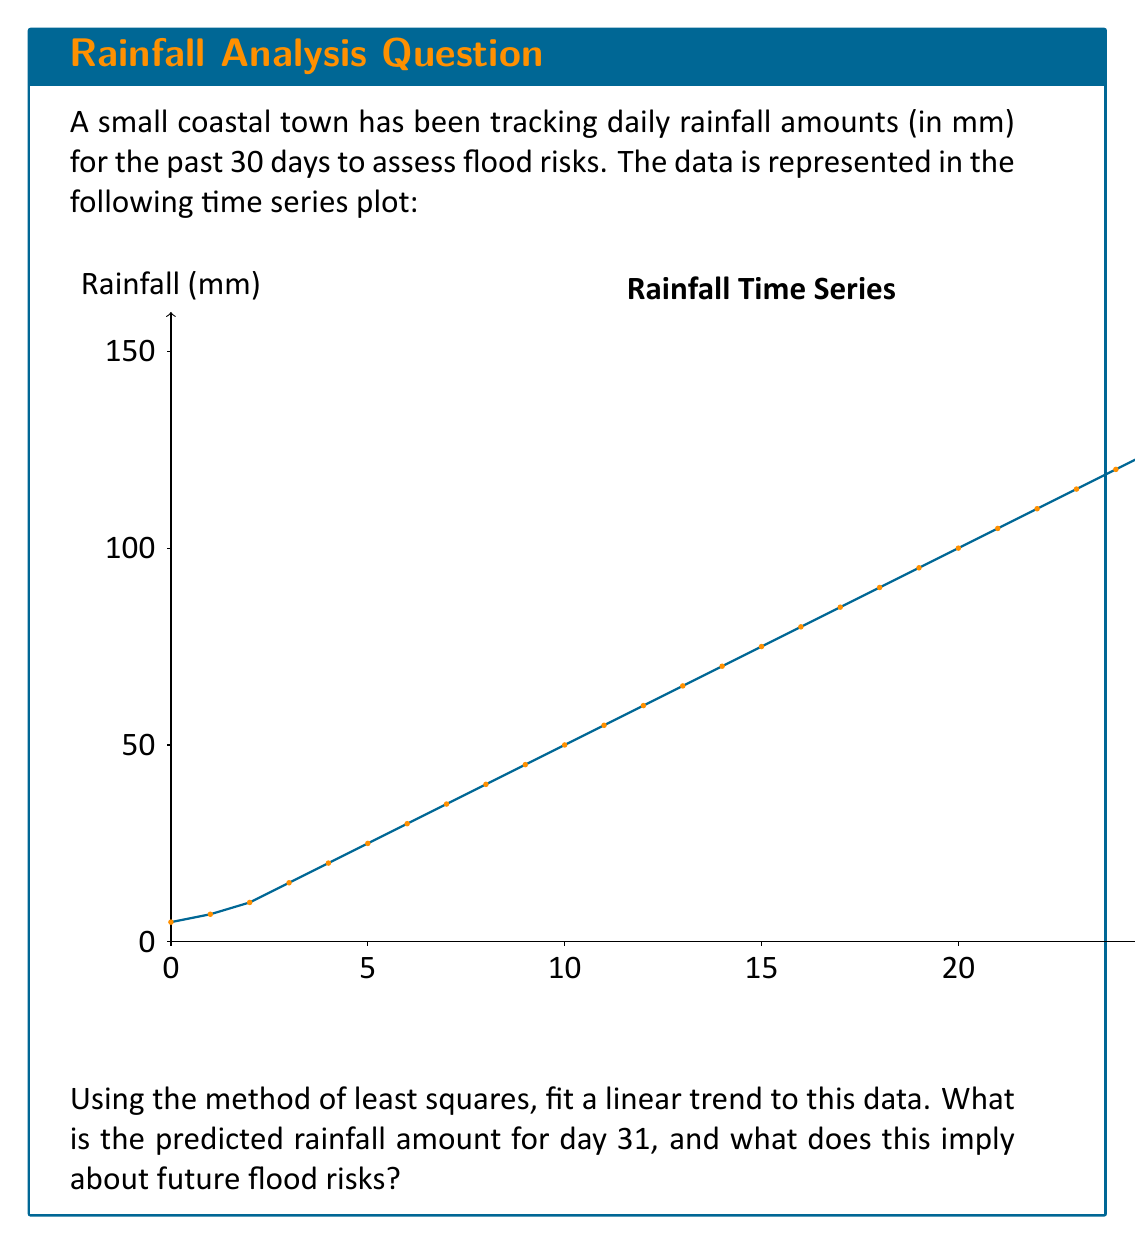Could you help me with this problem? To solve this problem, we'll follow these steps:

1) First, we need to calculate the parameters for the linear trend line $y = mx + b$, where $y$ is the rainfall amount, $x$ is the day number, $m$ is the slope, and $b$ is the y-intercept.

2) For the method of least squares, we use these formulas:

   $m = \frac{n\sum xy - \sum x \sum y}{n\sum x^2 - (\sum x)^2}$

   $b = \frac{\sum y - m\sum x}{n}$

   where $n$ is the number of data points (30 in this case).

3) Calculate the sums:
   $\sum x = 1 + 2 + ... + 30 = 465$
   $\sum y = 5 + 7 + ... + 145 = 2385$
   $\sum xy = 1(5) + 2(7) + ... + 30(145) = 65,780$
   $\sum x^2 = 1^2 + 2^2 + ... + 30^2 = 9,455$

4) Plug these into the formulas:

   $m = \frac{30(65,780) - 465(2385)}{30(9,455) - 465^2} = \frac{1,973,400 - 1,109,025}{283,650 - 216,225} \approx 4.83$

   $b = \frac{2385 - 4.83(465)}{30} \approx -0.69$

5) Our linear trend line equation is therefore:

   $y = 4.83x - 0.69$

6) To predict the rainfall for day 31, we substitute $x = 31$:

   $y = 4.83(31) - 0.69 = 149.04$

7) Interpreting the result: The predicted rainfall for day 31 is approximately 149.04 mm. This shows a strong increasing trend in daily rainfall.

8) Regarding flood risks: The steep positive slope (4.83 mm/day) indicates rapidly increasing rainfall amounts. If this trend continues, it suggests a significantly elevated risk of flooding in the near future, especially considering that the latest recorded rainfall (145 mm) is already quite high.
Answer: 149.04 mm; indicates high and increasing flood risk 